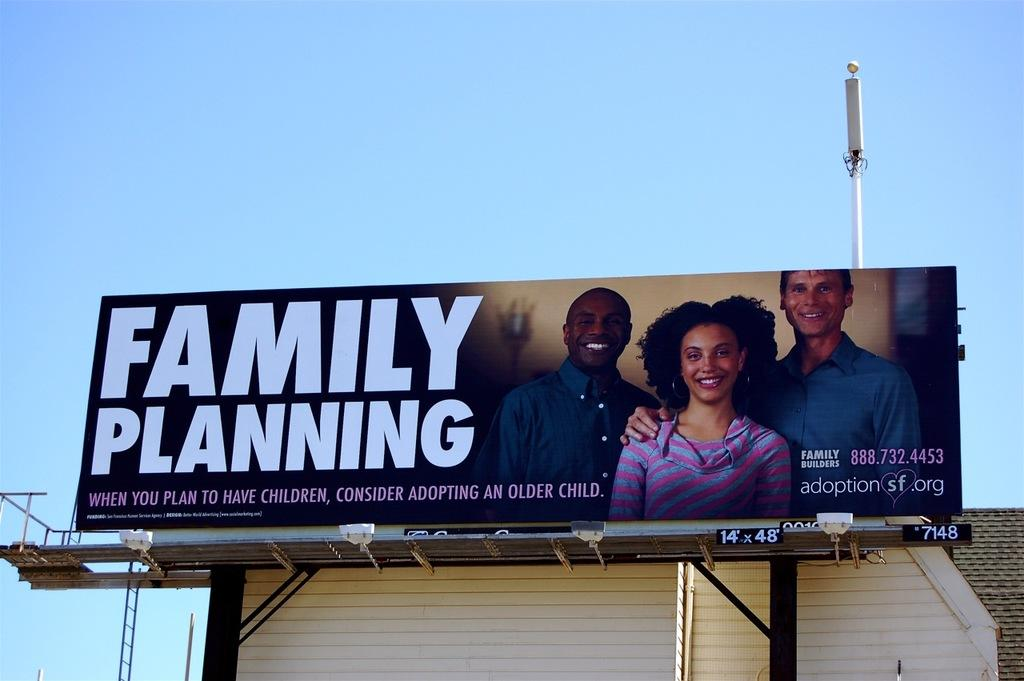<image>
Describe the image concisely. A large outdoor billboard that reads Family Planning. 